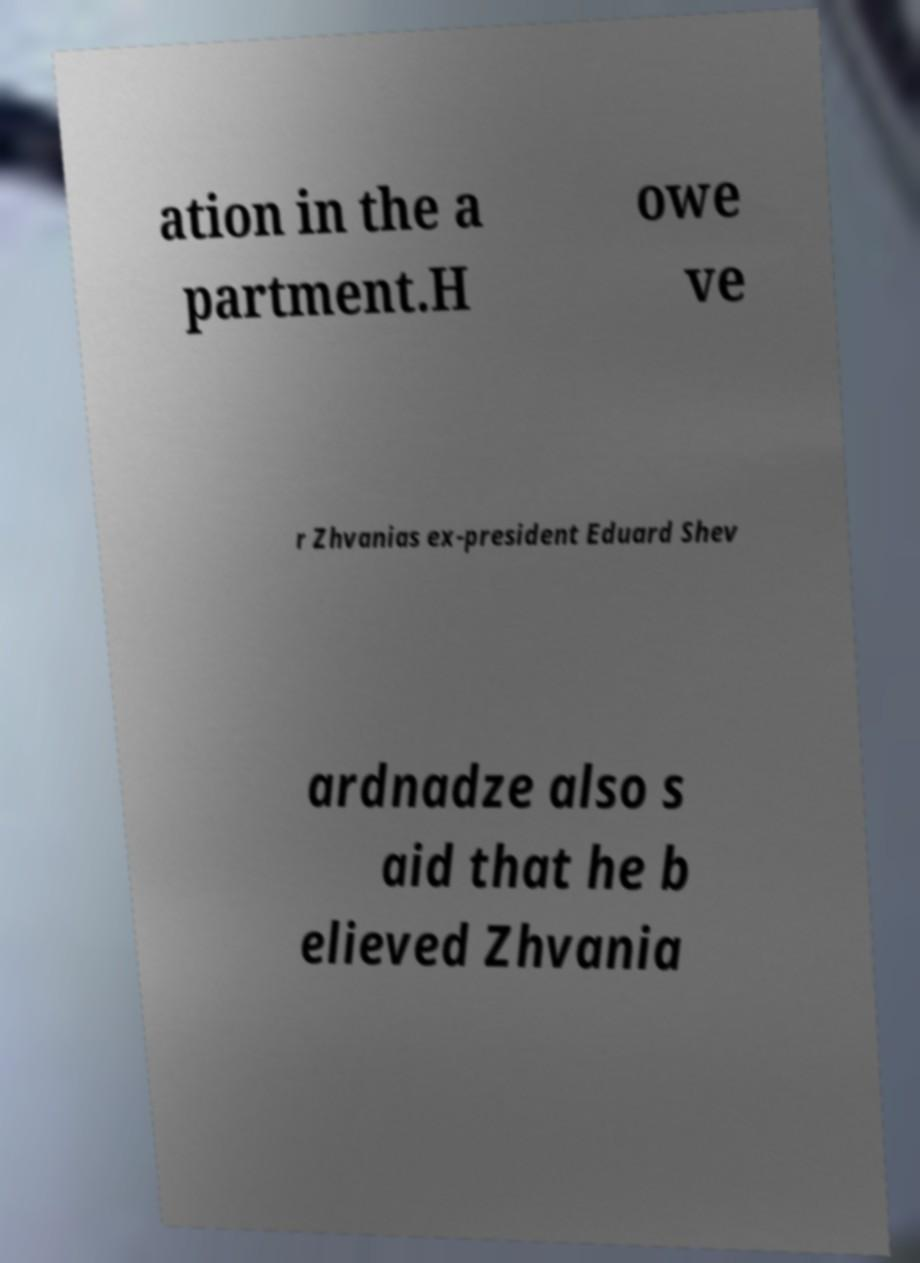I need the written content from this picture converted into text. Can you do that? ation in the a partment.H owe ve r Zhvanias ex-president Eduard Shev ardnadze also s aid that he b elieved Zhvania 